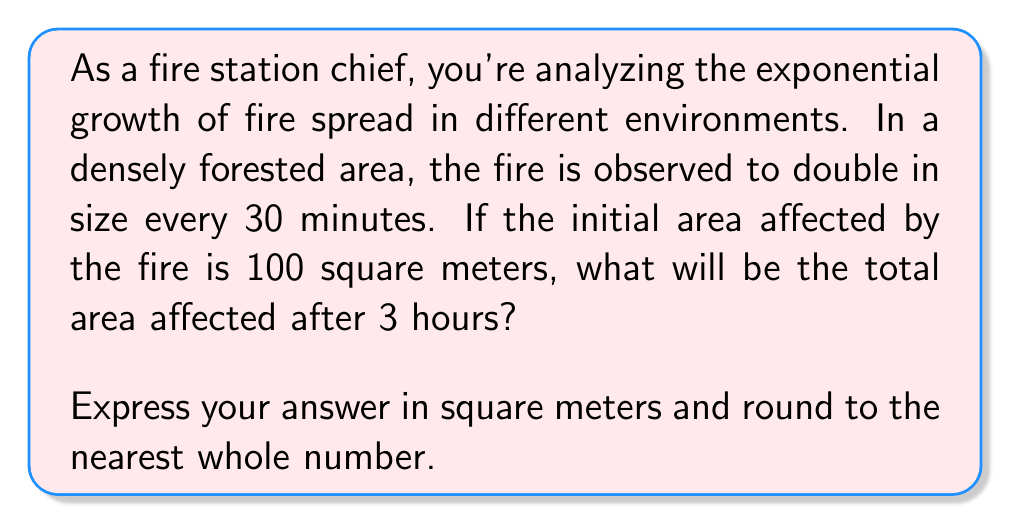Could you help me with this problem? To solve this problem, we need to use the exponential growth formula:

$$ A = A_0 \cdot 2^n $$

Where:
$A$ = Final area
$A_0$ = Initial area (100 square meters)
$n$ = Number of doubling periods

First, let's calculate how many doubling periods occur in 3 hours:

$$ \text{Number of doubling periods} = \frac{\text{Total time}}{\text{Time for one doubling}} = \frac{3 \text{ hours}}{0.5 \text{ hours}} = 6 $$

Now we can plug these values into our exponential growth formula:

$$ A = 100 \cdot 2^6 $$

To calculate this:

$$ \begin{align}
A &= 100 \cdot 2^6 \\
&= 100 \cdot 64 \\
&= 6400 \text{ square meters}
\end{align} $$

Therefore, after 3 hours, the fire will have spread to an area of 6400 square meters.
Answer: 6400 square meters 